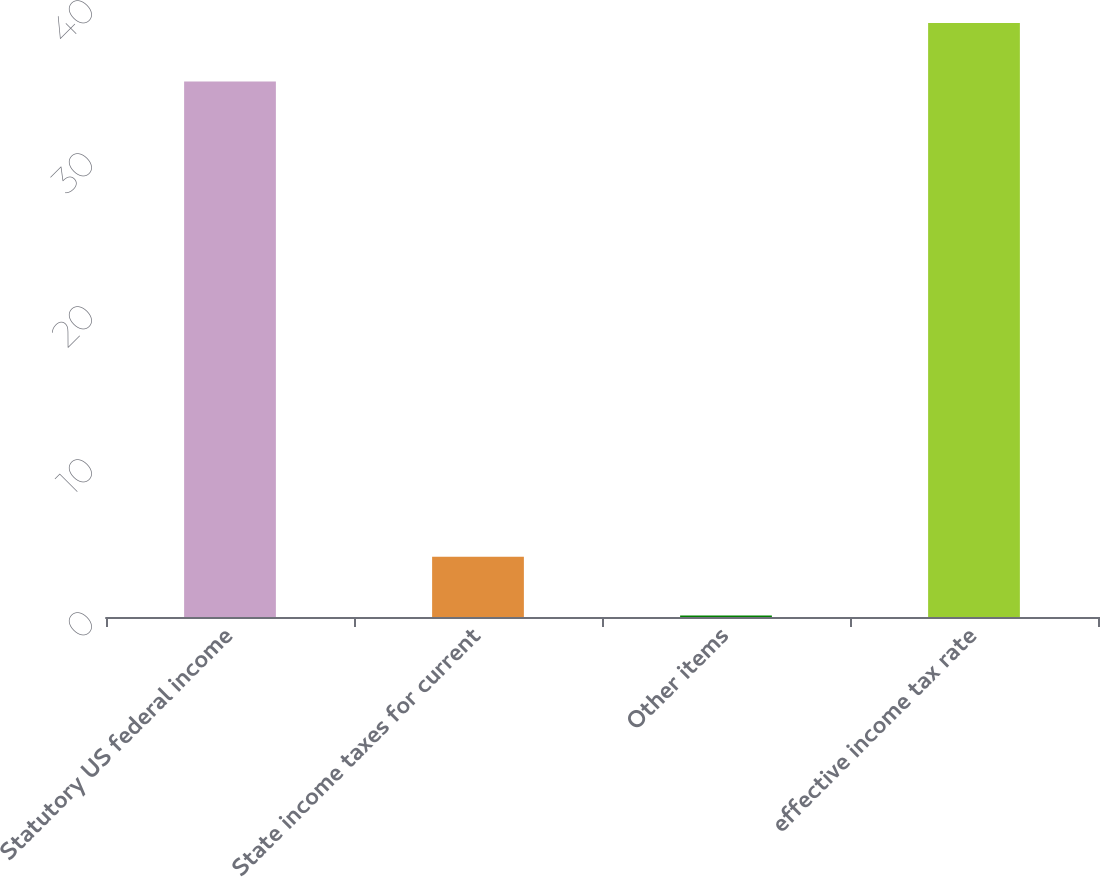Convert chart. <chart><loc_0><loc_0><loc_500><loc_500><bar_chart><fcel>Statutory US federal income<fcel>State income taxes for current<fcel>Other items<fcel>effective income tax rate<nl><fcel>35<fcel>3.93<fcel>0.1<fcel>38.83<nl></chart> 